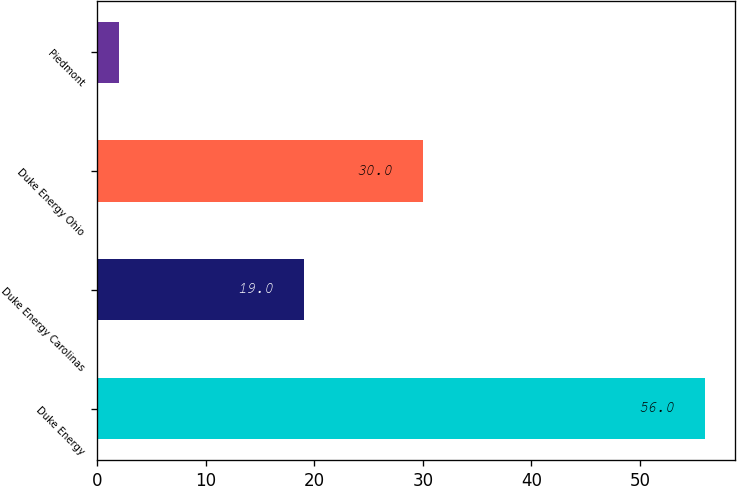Convert chart to OTSL. <chart><loc_0><loc_0><loc_500><loc_500><bar_chart><fcel>Duke Energy<fcel>Duke Energy Carolinas<fcel>Duke Energy Ohio<fcel>Piedmont<nl><fcel>56<fcel>19<fcel>30<fcel>2<nl></chart> 